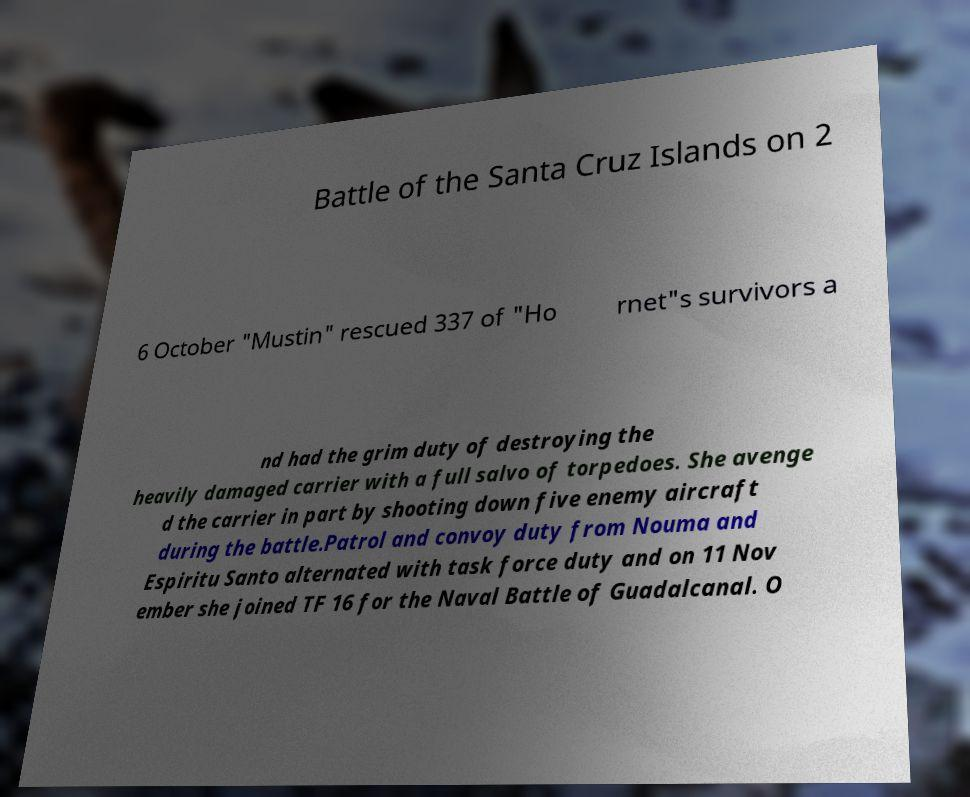What messages or text are displayed in this image? I need them in a readable, typed format. Battle of the Santa Cruz Islands on 2 6 October "Mustin" rescued 337 of "Ho rnet"s survivors a nd had the grim duty of destroying the heavily damaged carrier with a full salvo of torpedoes. She avenge d the carrier in part by shooting down five enemy aircraft during the battle.Patrol and convoy duty from Nouma and Espiritu Santo alternated with task force duty and on 11 Nov ember she joined TF 16 for the Naval Battle of Guadalcanal. O 